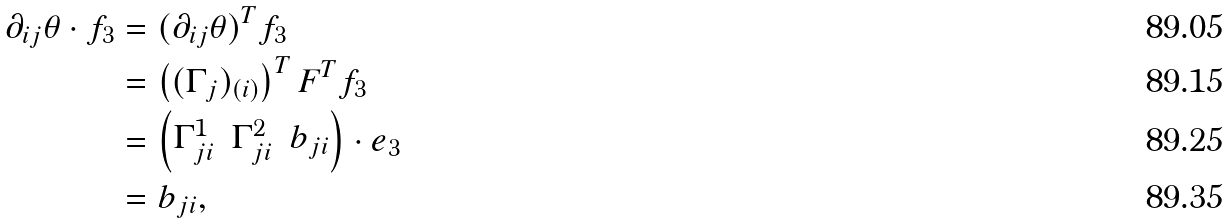Convert formula to latex. <formula><loc_0><loc_0><loc_500><loc_500>\partial _ { i j } \theta \cdot f _ { 3 } & = ( \partial _ { i j } \theta ) ^ { T } f _ { 3 } \\ & = \left ( ( \Gamma _ { j } ) _ { ( i ) } \right ) ^ { T } F ^ { T } f _ { 3 } \\ & = \begin{pmatrix} \Gamma ^ { 1 } _ { j i } & \Gamma ^ { 2 } _ { j i } & b _ { j i } \end{pmatrix} \cdot e _ { 3 } \\ & = b _ { j i } ,</formula> 